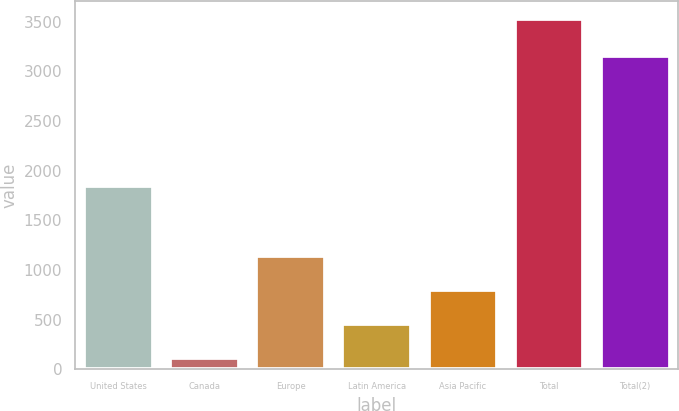Convert chart. <chart><loc_0><loc_0><loc_500><loc_500><bar_chart><fcel>United States<fcel>Canada<fcel>Europe<fcel>Latin America<fcel>Asia Pacific<fcel>Total<fcel>Total(2)<nl><fcel>1844.8<fcel>113.7<fcel>1139.16<fcel>455.52<fcel>797.34<fcel>3531.9<fcel>3155.8<nl></chart> 